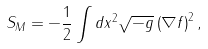<formula> <loc_0><loc_0><loc_500><loc_500>S _ { M } = - \frac { 1 } { 2 } \int d x ^ { 2 } \sqrt { - g } \left ( \nabla f \right ) ^ { 2 } ,</formula> 